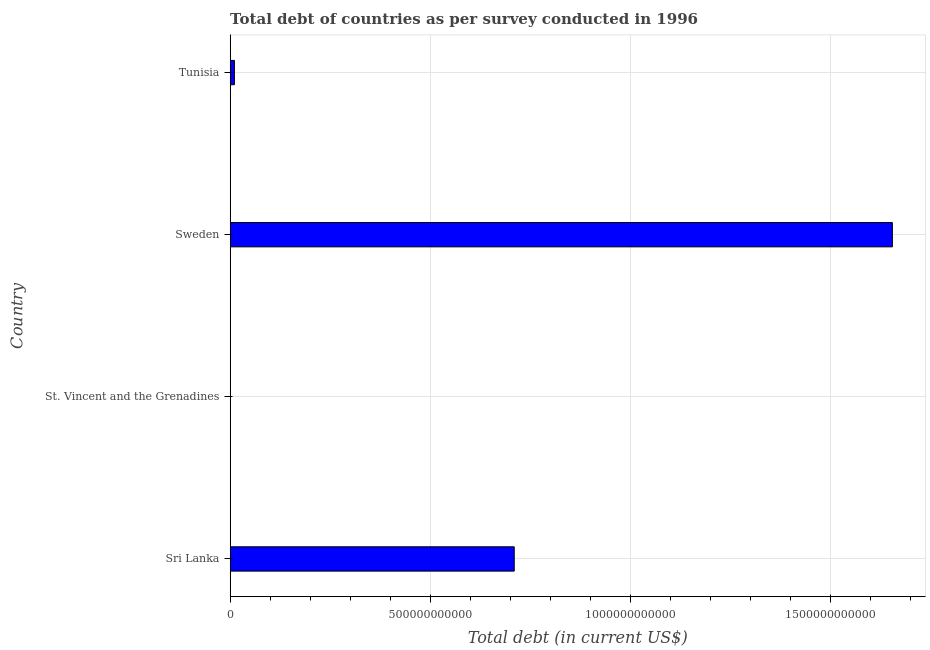Does the graph contain any zero values?
Keep it short and to the point. No. Does the graph contain grids?
Your answer should be very brief. Yes. What is the title of the graph?
Keep it short and to the point. Total debt of countries as per survey conducted in 1996. What is the label or title of the X-axis?
Your answer should be very brief. Total debt (in current US$). What is the label or title of the Y-axis?
Offer a very short reply. Country. What is the total debt in Sweden?
Provide a succinct answer. 1.65e+12. Across all countries, what is the maximum total debt?
Provide a short and direct response. 1.65e+12. Across all countries, what is the minimum total debt?
Provide a succinct answer. 3.72e+08. In which country was the total debt maximum?
Your answer should be compact. Sweden. In which country was the total debt minimum?
Your response must be concise. St. Vincent and the Grenadines. What is the sum of the total debt?
Your response must be concise. 2.37e+12. What is the difference between the total debt in St. Vincent and the Grenadines and Sweden?
Offer a very short reply. -1.65e+12. What is the average total debt per country?
Ensure brevity in your answer.  5.93e+11. What is the median total debt?
Your answer should be compact. 3.60e+11. In how many countries, is the total debt greater than 1100000000000 US$?
Make the answer very short. 1. What is the ratio of the total debt in Sweden to that in Tunisia?
Offer a terse response. 156.85. Is the total debt in Sri Lanka less than that in Tunisia?
Your response must be concise. No. What is the difference between the highest and the second highest total debt?
Your answer should be compact. 9.44e+11. What is the difference between the highest and the lowest total debt?
Give a very brief answer. 1.65e+12. In how many countries, is the total debt greater than the average total debt taken over all countries?
Keep it short and to the point. 2. How many countries are there in the graph?
Ensure brevity in your answer.  4. What is the difference between two consecutive major ticks on the X-axis?
Your answer should be compact. 5.00e+11. What is the Total debt (in current US$) of Sri Lanka?
Provide a succinct answer. 7.09e+11. What is the Total debt (in current US$) of St. Vincent and the Grenadines?
Your response must be concise. 3.72e+08. What is the Total debt (in current US$) in Sweden?
Offer a terse response. 1.65e+12. What is the Total debt (in current US$) in Tunisia?
Your answer should be very brief. 1.05e+1. What is the difference between the Total debt (in current US$) in Sri Lanka and St. Vincent and the Grenadines?
Make the answer very short. 7.09e+11. What is the difference between the Total debt (in current US$) in Sri Lanka and Sweden?
Offer a terse response. -9.44e+11. What is the difference between the Total debt (in current US$) in Sri Lanka and Tunisia?
Ensure brevity in your answer.  6.99e+11. What is the difference between the Total debt (in current US$) in St. Vincent and the Grenadines and Sweden?
Ensure brevity in your answer.  -1.65e+12. What is the difference between the Total debt (in current US$) in St. Vincent and the Grenadines and Tunisia?
Offer a terse response. -1.02e+1. What is the difference between the Total debt (in current US$) in Sweden and Tunisia?
Your answer should be compact. 1.64e+12. What is the ratio of the Total debt (in current US$) in Sri Lanka to that in St. Vincent and the Grenadines?
Your answer should be very brief. 1904.73. What is the ratio of the Total debt (in current US$) in Sri Lanka to that in Sweden?
Your response must be concise. 0.43. What is the ratio of the Total debt (in current US$) in Sri Lanka to that in Tunisia?
Ensure brevity in your answer.  67.28. What is the ratio of the Total debt (in current US$) in St. Vincent and the Grenadines to that in Tunisia?
Provide a succinct answer. 0.04. What is the ratio of the Total debt (in current US$) in Sweden to that in Tunisia?
Offer a very short reply. 156.85. 